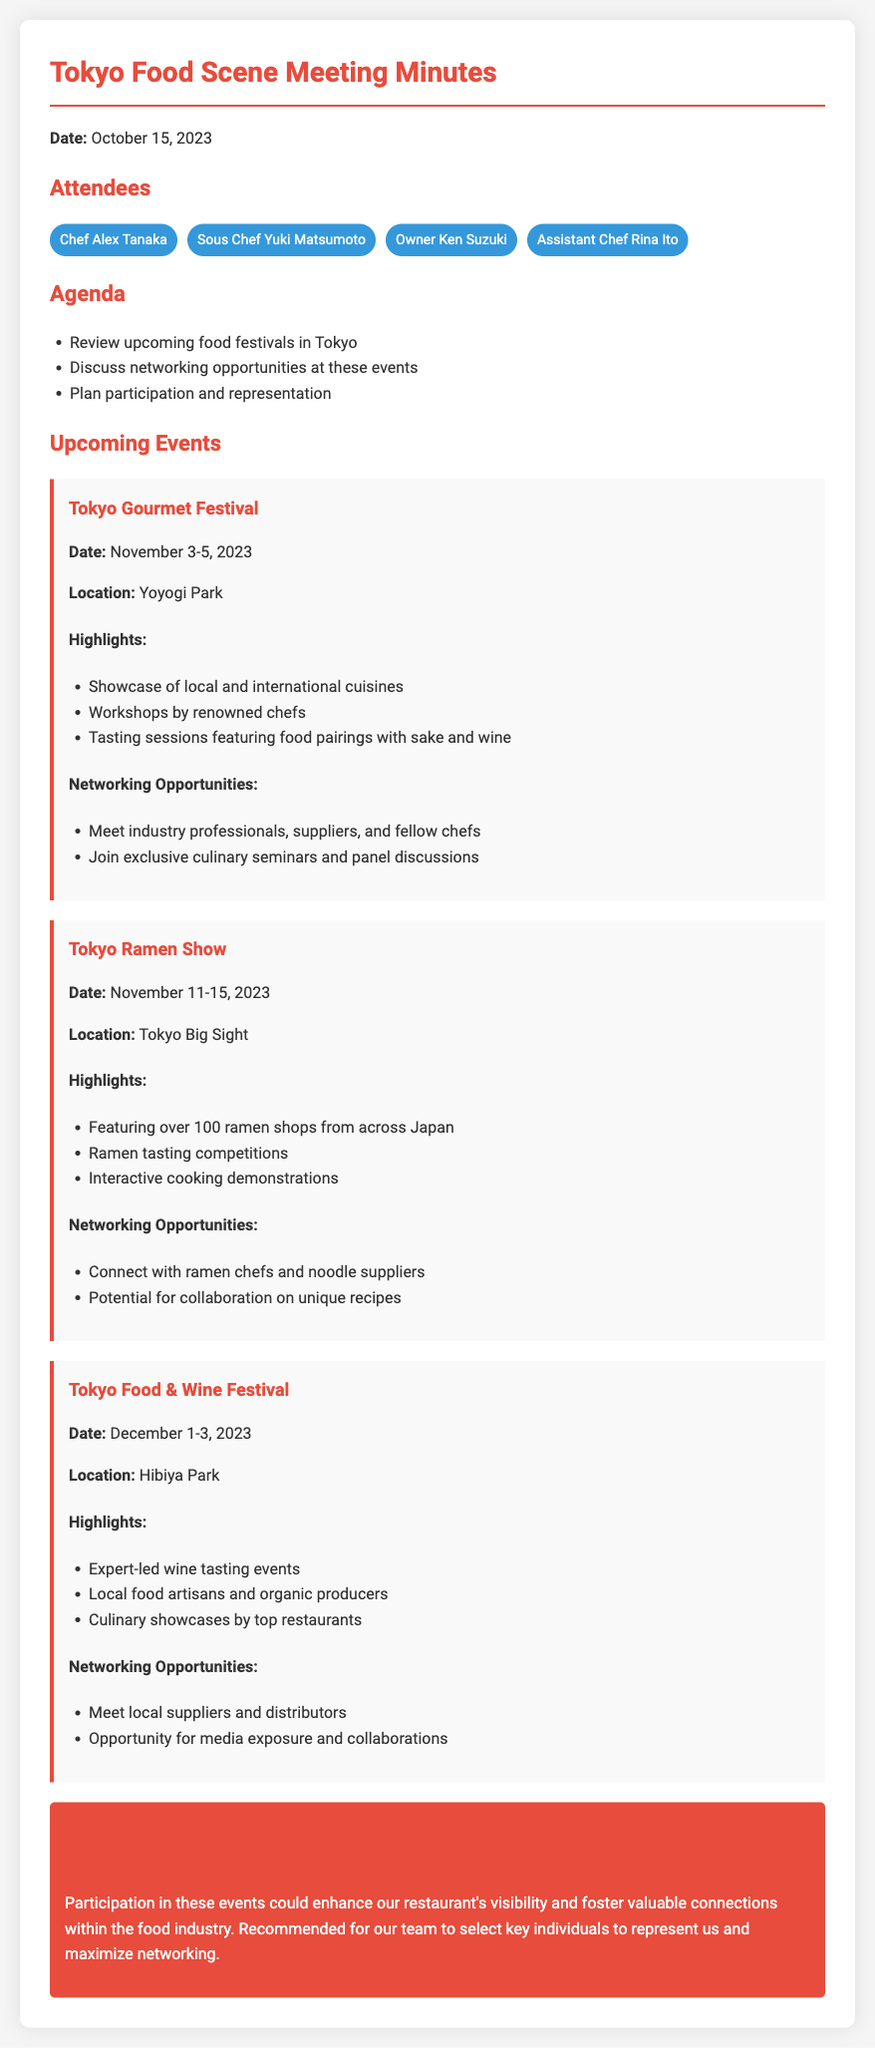What is the date of the Tokyo Gourmet Festival? The document states that the Tokyo Gourmet Festival is scheduled from November 3-5, 2023.
Answer: November 3-5, 2023 Where will the Tokyo Ramen Show be held? The location mentioned for the Tokyo Ramen Show is Tokyo Big Sight.
Answer: Tokyo Big Sight What are the highlights of the Tokyo Food & Wine Festival? The document lists expert-led wine tasting events, local food artisans, and culinary showcases as highlights.
Answer: Expert-led wine tasting events, local food artisans, culinary showcases What opportunity is mentioned for the Tokyo Gourmet Festival? The document highlights networking opportunities; it mentions meeting industry professionals, suppliers, and fellow chefs.
Answer: Meet industry professionals, suppliers, and fellow chefs Which event focuses on ramen? The document clearly states that the Tokyo Ramen Show features over 100 ramen shops.
Answer: Tokyo Ramen Show What is one of the reasons for participation in these events? The conclusion emphasizes that participation could enhance visibility and foster valuable connections within the food industry.
Answer: Enhance visibility and foster valuable connections How many attendees were listed in the meeting minutes? The document provides the names of four attendees who participated in the meeting.
Answer: Four What is a recommended action from the meeting minutes? It suggests that the team should select key individuals to represent the restaurant at the events.
Answer: Select key individuals to represent us 